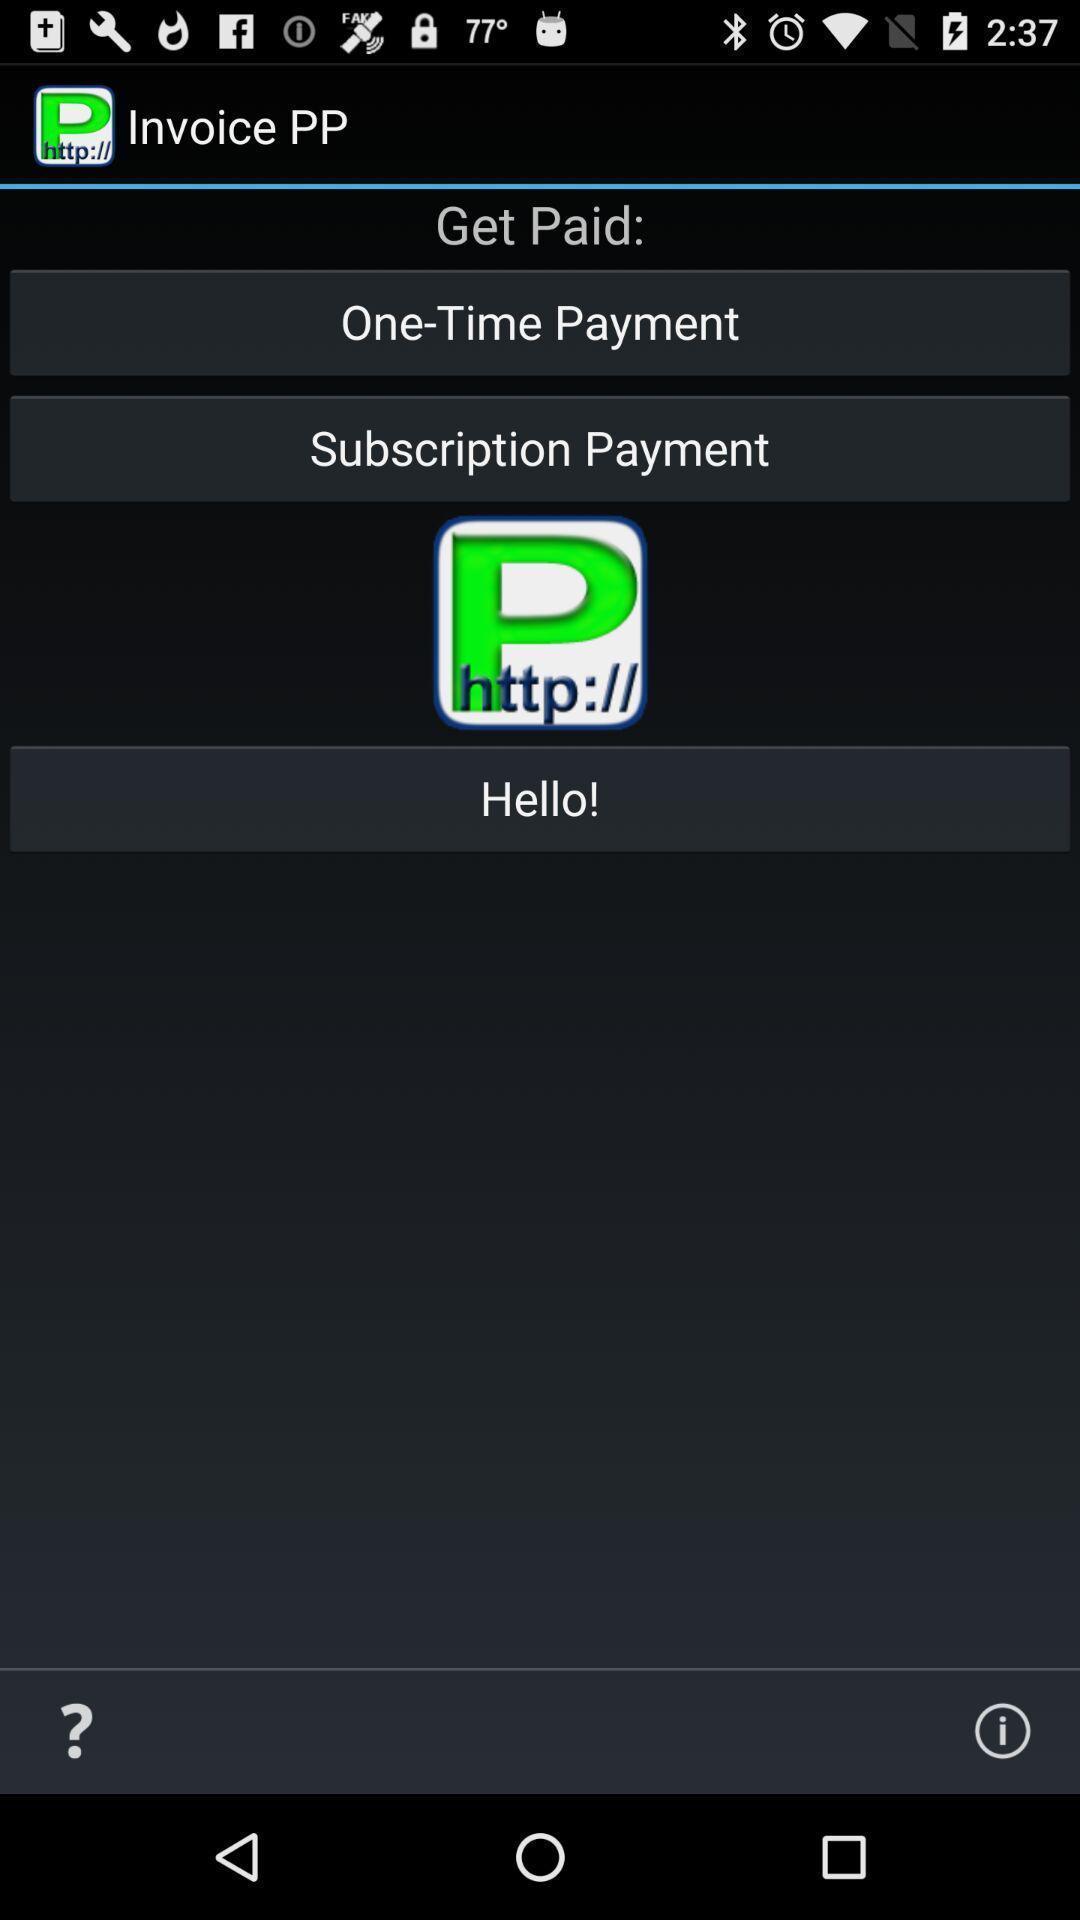Describe this image in words. Starting page. 